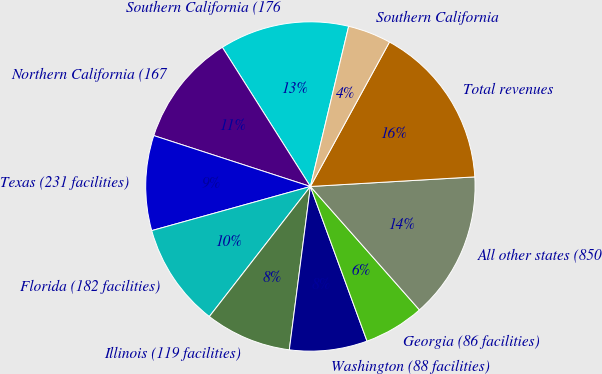Convert chart. <chart><loc_0><loc_0><loc_500><loc_500><pie_chart><fcel>Southern California (176<fcel>Northern California (167<fcel>Texas (231 facilities)<fcel>Florida (182 facilities)<fcel>Illinois (119 facilities)<fcel>Washington (88 facilities)<fcel>Georgia (86 facilities)<fcel>All other states (850<fcel>Total revenues<fcel>Southern California<nl><fcel>12.71%<fcel>11.02%<fcel>9.32%<fcel>10.17%<fcel>8.47%<fcel>7.63%<fcel>5.93%<fcel>14.41%<fcel>16.1%<fcel>4.24%<nl></chart> 